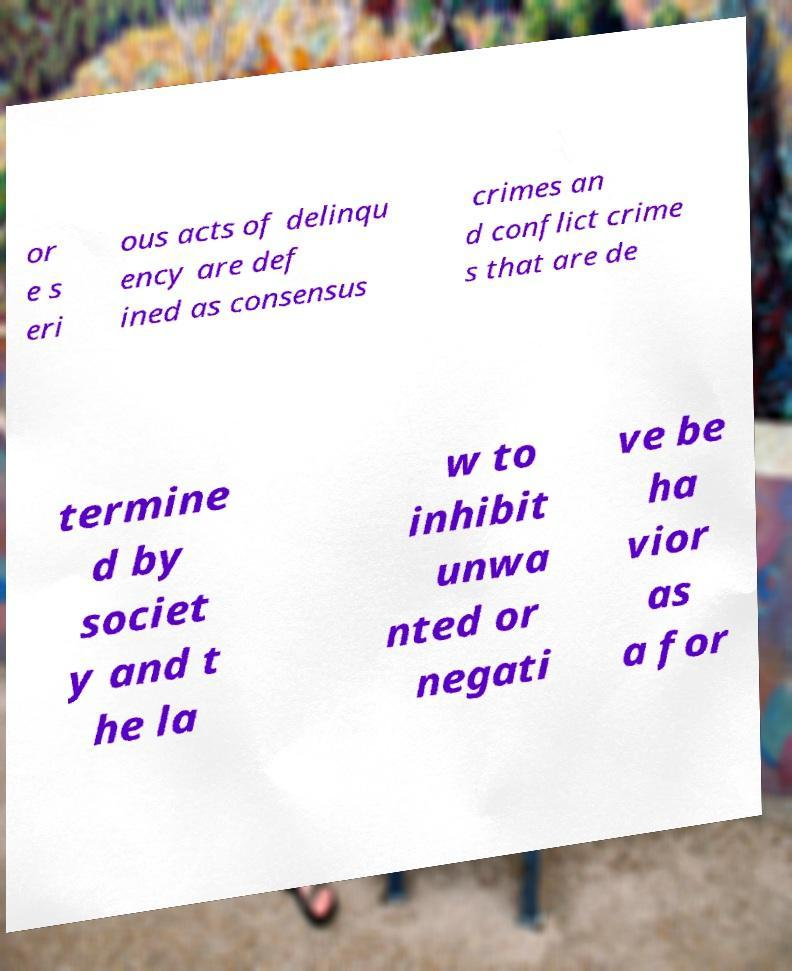Please identify and transcribe the text found in this image. or e s eri ous acts of delinqu ency are def ined as consensus crimes an d conflict crime s that are de termine d by societ y and t he la w to inhibit unwa nted or negati ve be ha vior as a for 